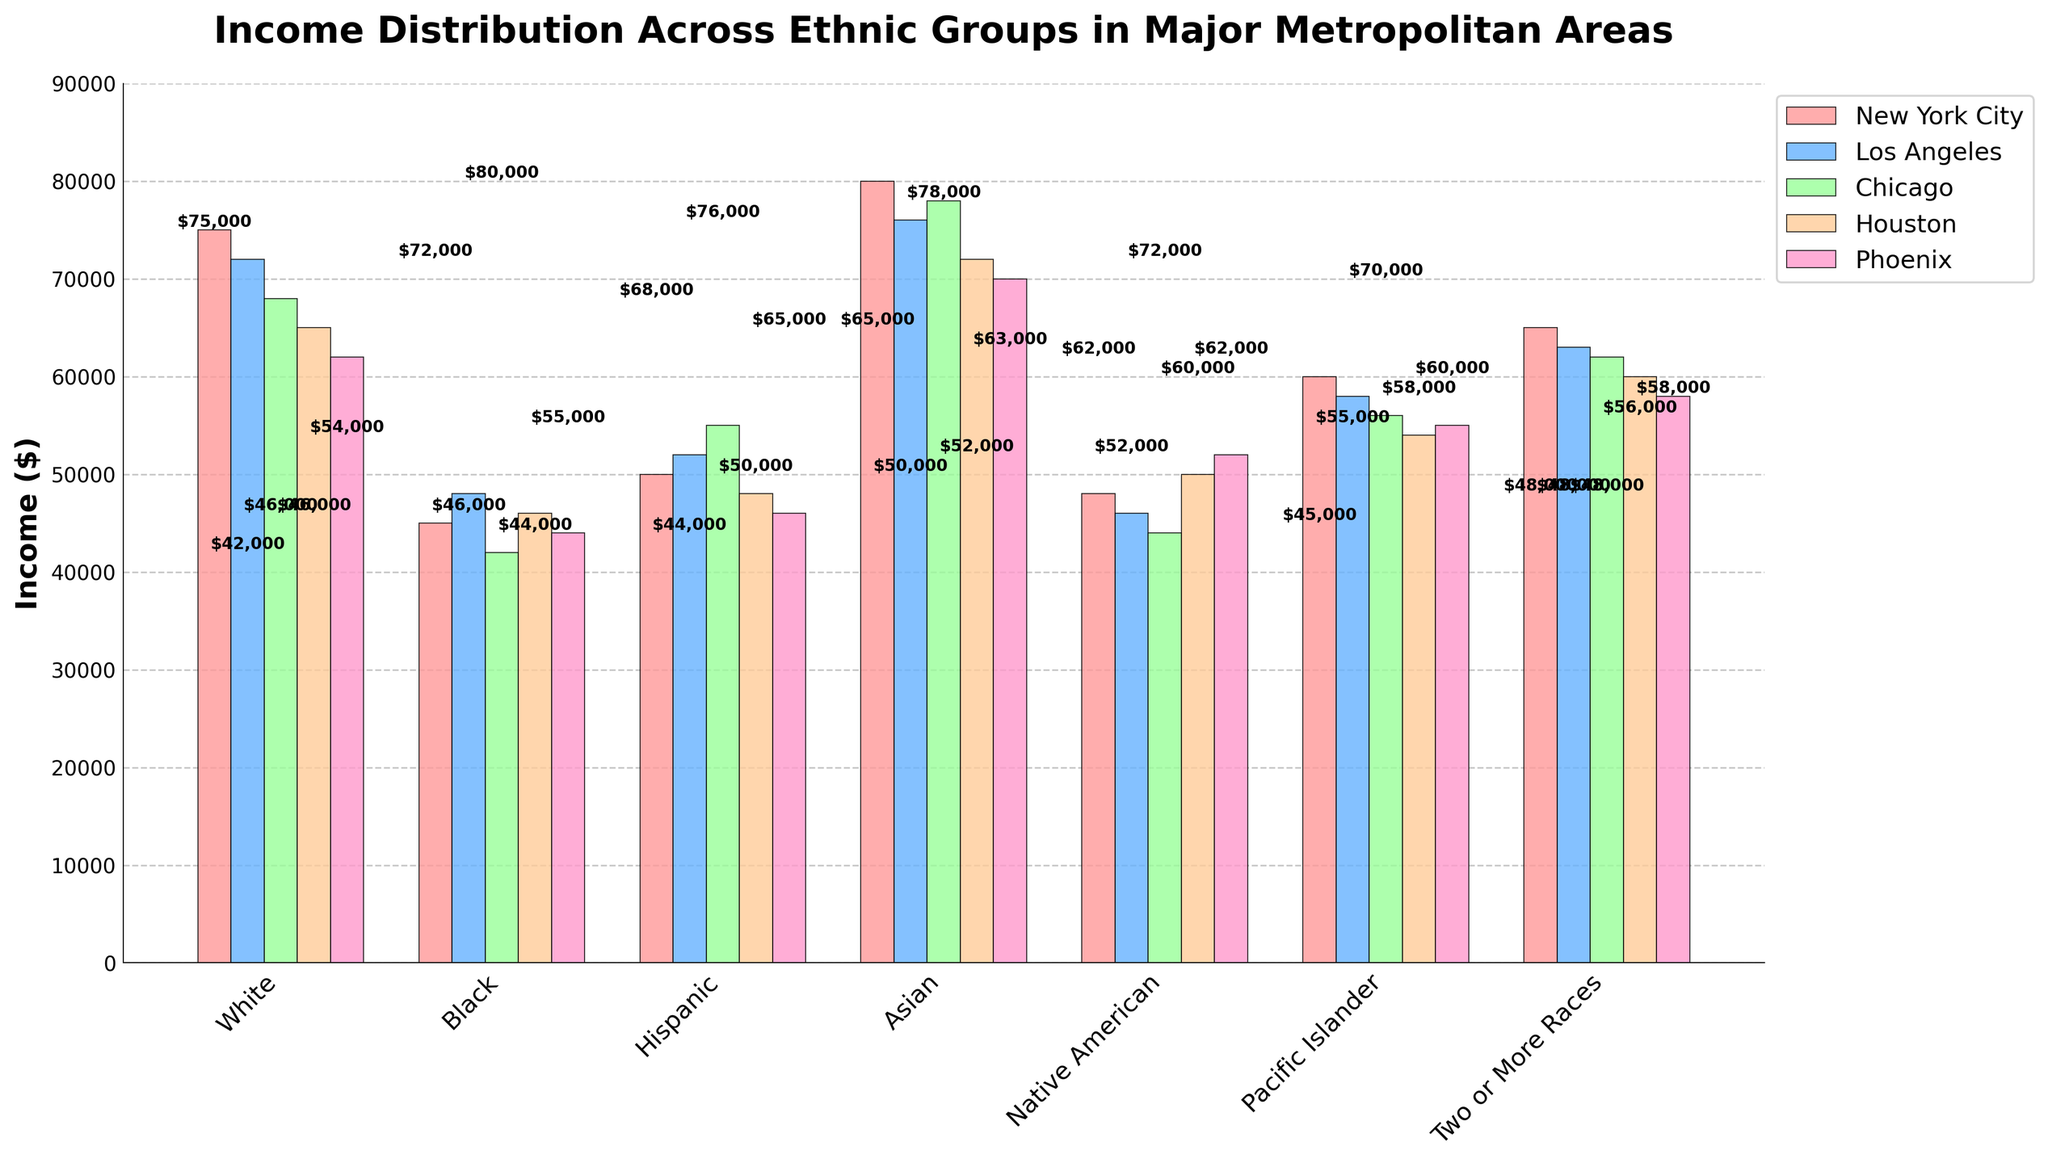What is the average income of Asian individuals across all the cities? To find the average, sum all the income values for Asian individuals across the cities and then divide it by the number of cities. Sum: 80000 (NYC) + 76000 (LA) + 78000 (Chicago) + 72000 (Houston) + 70000 (Phoenix) = 376000. There are 5 cities, so Average = 376000 / 5
Answer: 75200 Which ethnic group has the highest income in Los Angeles? Observing the bar heights for all ethnic groups in Los Angeles, Asian individuals have the highest bar, with an income of $76000.
Answer: Asian Is the income of Hispanic individuals in Chicago higher or lower than in Los Angeles? Refer to the bar chart for Hispanic individuals in both cities. In Chicago, the income value is $55000, while in Los Angeles, it is $52000. $55000 is higher than $52000.
Answer: Higher Which city has the lowest income value for any ethnic group, and what is that value? To find the lowest income value, look for the shortest bar across all ethnic groups in all cities. The Black individuals in Chicago have the lowest bar as $42000 is the smallest when compared to all other values.
Answer: Chicago, $42000 What is the total combined income of Pacific Islander individuals across all cities? Sum the income values for Pacific Islander individuals in all cities. Sum: 60000 (NYC) + 58000 (LA) + 56000 (Chicago) + 54000 (Houston) + 55000 (Phoenix) = 283000
Answer: 283000 Is the income for Two or More Races in Phoenix higher or lower than in Houston? Compare the bar heights for Two or More Races individuals in Phoenix and Houston. The value in Phoenix is $58000 and in Houston it is $60000. $58000 is lower than $60000.
Answer: Lower What is the income difference between Native American individuals and Black individuals in New York City? Subtract the income for Black individuals from that of Native American individuals in New York City. The income for Native American individuals in NYC is $48000, and for Black individuals, it is $45000. Difference: $48000 - $45000 = $3000
Answer: $3000 Which ethnic group's income in Houston is closest to $50000? Observe the bars listing $50000 income closely in Houston. The Native American individuals have an income of $50000, which is exactly $50000.
Answer: Native American Are there any ethnic groups whose income is consistently decreasing from New York City to Phoenix? Examine the bars sequentially from New York to Phoenix for each ethnic group. White individuals show a consistent decrease: $75000 (NYC) > $72000 (LA) > $68000 (Chicago) > $65000 (Houston) > $62000 (Phoenix).
Answer: White 